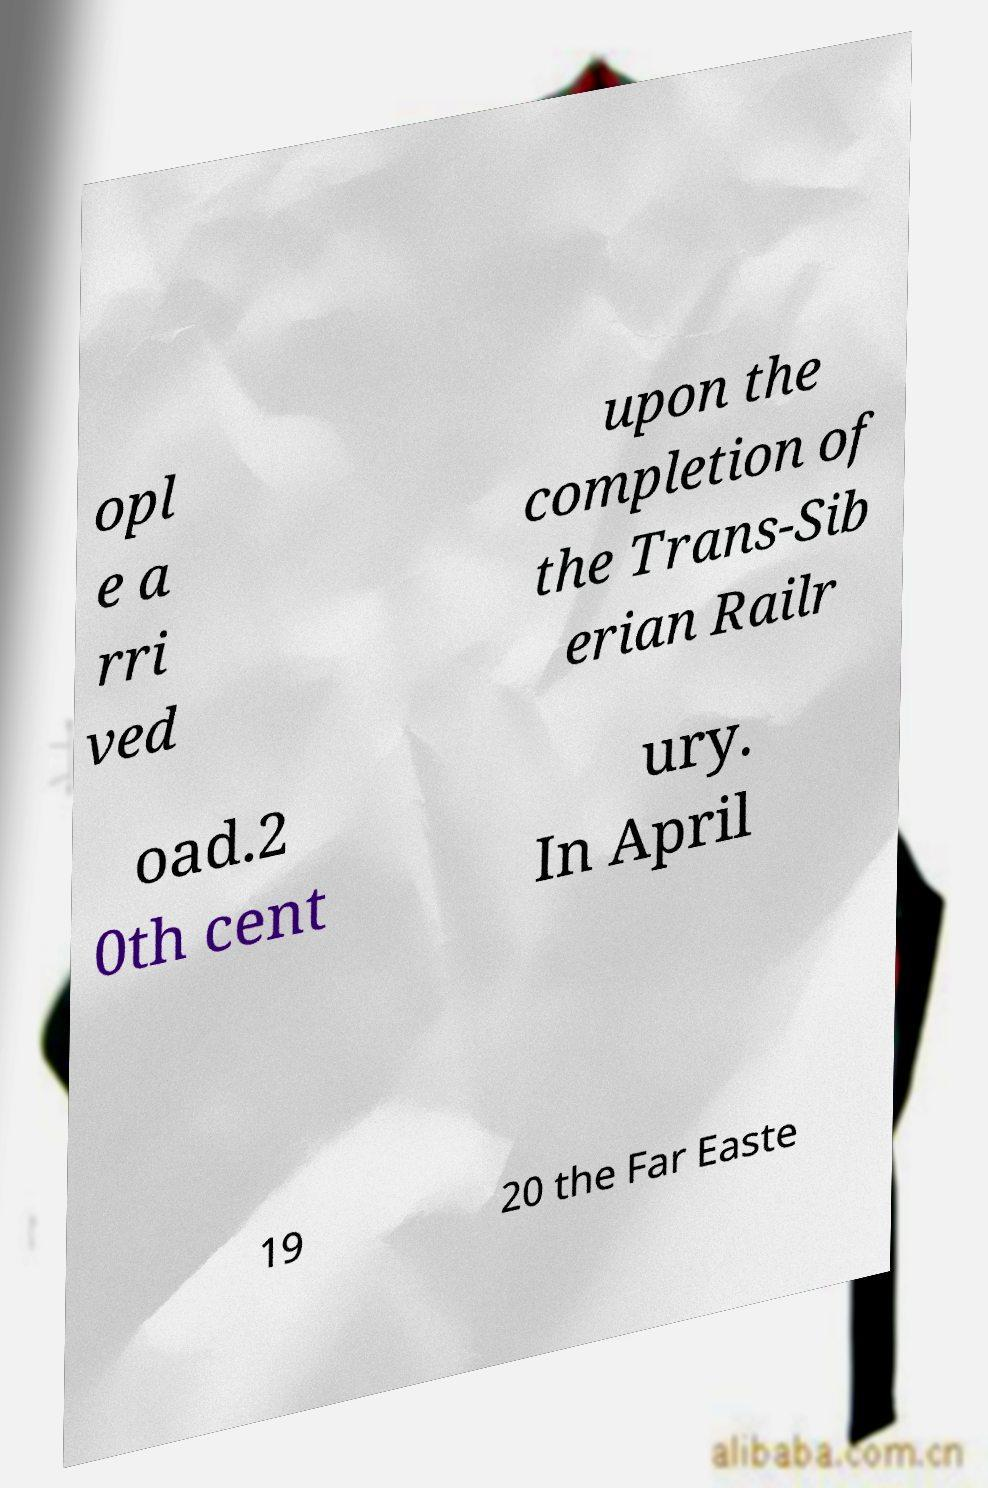There's text embedded in this image that I need extracted. Can you transcribe it verbatim? opl e a rri ved upon the completion of the Trans-Sib erian Railr oad.2 0th cent ury. In April 19 20 the Far Easte 